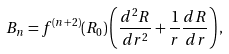Convert formula to latex. <formula><loc_0><loc_0><loc_500><loc_500>B _ { n } = f ^ { ( n + 2 ) } ( R _ { 0 } ) \left ( \frac { d ^ { 2 } R } { d r ^ { 2 } } + \frac { 1 } { r } \frac { d R } { d r } \right ) ,</formula> 